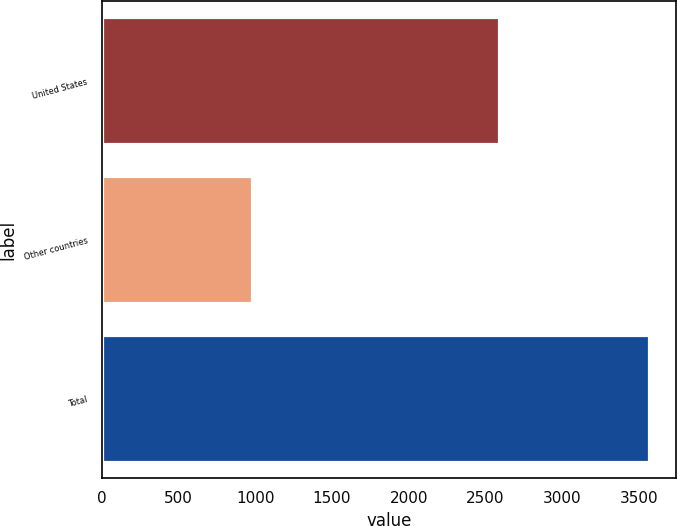<chart> <loc_0><loc_0><loc_500><loc_500><bar_chart><fcel>United States<fcel>Other countries<fcel>Total<nl><fcel>2587.1<fcel>978.4<fcel>3565.5<nl></chart> 